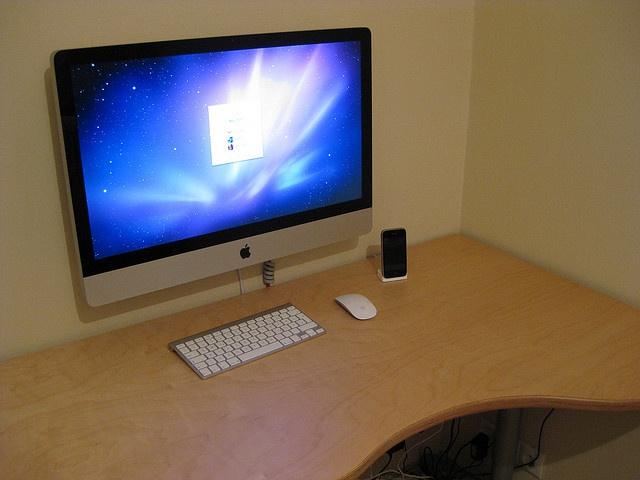Describe the objects in this image and their specific colors. I can see tv in gray, black, blue, and lavender tones, keyboard in gray, darkgray, and maroon tones, cell phone in gray and black tones, and mouse in gray, darkgray, and maroon tones in this image. 